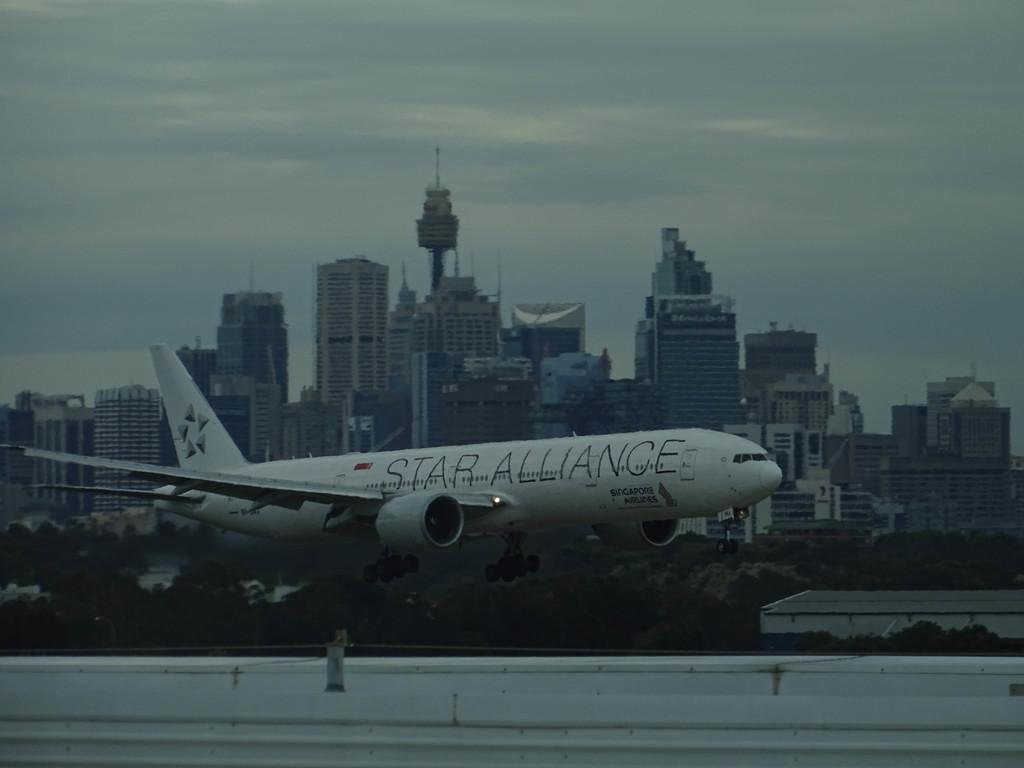<image>
Relay a brief, clear account of the picture shown. Star Alliance plane on runway in city with tall buildings 